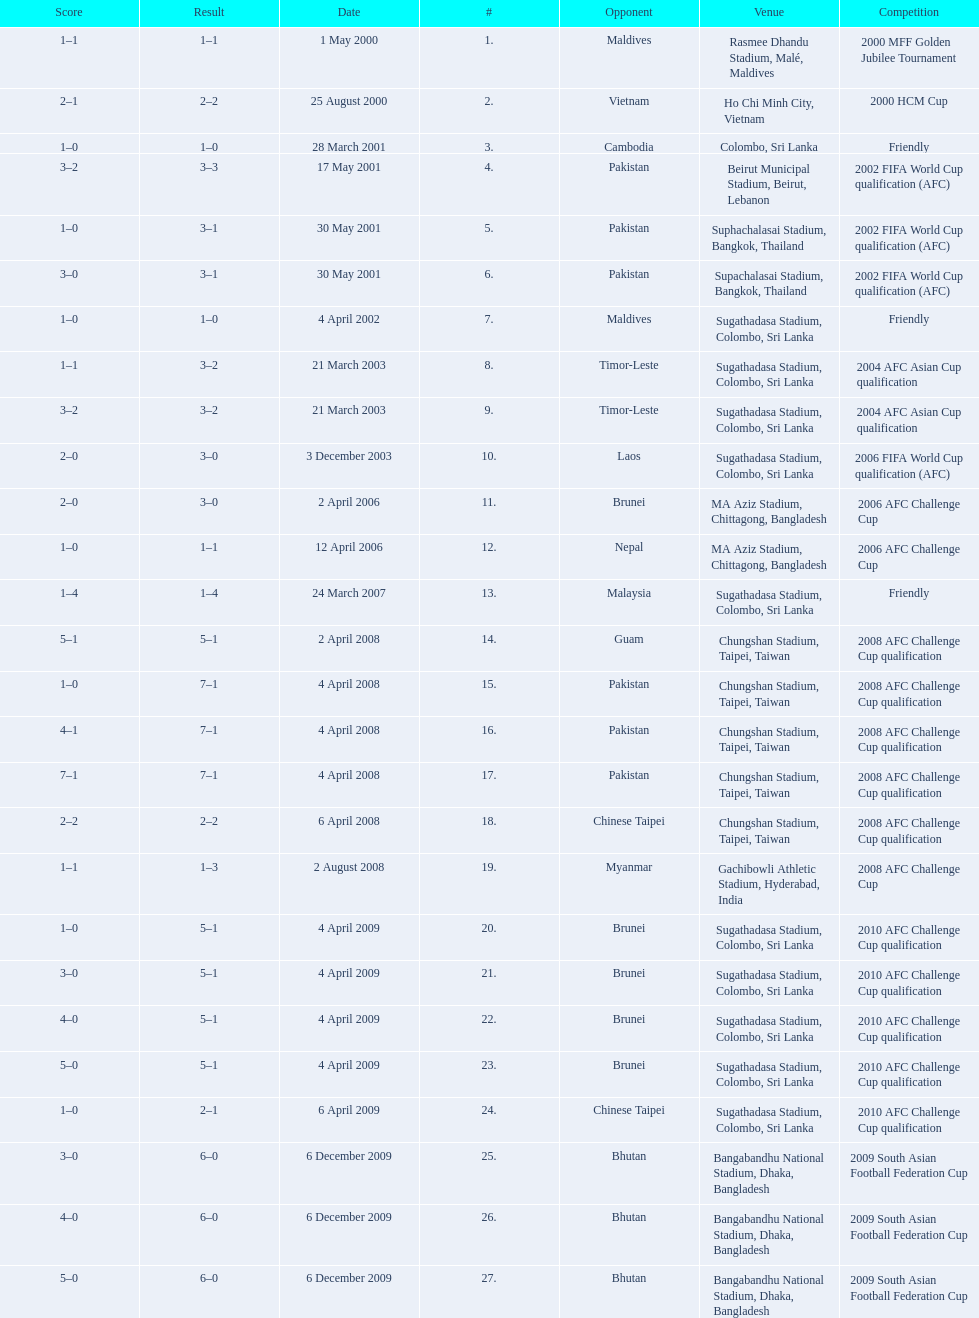Can you give me this table as a dict? {'header': ['Score', 'Result', 'Date', '#', 'Opponent', 'Venue', 'Competition'], 'rows': [['1–1', '1–1', '1 May 2000', '1.', 'Maldives', 'Rasmee Dhandu Stadium, Malé, Maldives', '2000 MFF Golden Jubilee Tournament'], ['2–1', '2–2', '25 August 2000', '2.', 'Vietnam', 'Ho Chi Minh City, Vietnam', '2000 HCM Cup'], ['1–0', '1–0', '28 March 2001', '3.', 'Cambodia', 'Colombo, Sri Lanka', 'Friendly'], ['3–2', '3–3', '17 May 2001', '4.', 'Pakistan', 'Beirut Municipal Stadium, Beirut, Lebanon', '2002 FIFA World Cup qualification (AFC)'], ['1–0', '3–1', '30 May 2001', '5.', 'Pakistan', 'Suphachalasai Stadium, Bangkok, Thailand', '2002 FIFA World Cup qualification (AFC)'], ['3–0', '3–1', '30 May 2001', '6.', 'Pakistan', 'Supachalasai Stadium, Bangkok, Thailand', '2002 FIFA World Cup qualification (AFC)'], ['1–0', '1–0', '4 April 2002', '7.', 'Maldives', 'Sugathadasa Stadium, Colombo, Sri Lanka', 'Friendly'], ['1–1', '3–2', '21 March 2003', '8.', 'Timor-Leste', 'Sugathadasa Stadium, Colombo, Sri Lanka', '2004 AFC Asian Cup qualification'], ['3–2', '3–2', '21 March 2003', '9.', 'Timor-Leste', 'Sugathadasa Stadium, Colombo, Sri Lanka', '2004 AFC Asian Cup qualification'], ['2–0', '3–0', '3 December 2003', '10.', 'Laos', 'Sugathadasa Stadium, Colombo, Sri Lanka', '2006 FIFA World Cup qualification (AFC)'], ['2–0', '3–0', '2 April 2006', '11.', 'Brunei', 'MA Aziz Stadium, Chittagong, Bangladesh', '2006 AFC Challenge Cup'], ['1–0', '1–1', '12 April 2006', '12.', 'Nepal', 'MA Aziz Stadium, Chittagong, Bangladesh', '2006 AFC Challenge Cup'], ['1–4', '1–4', '24 March 2007', '13.', 'Malaysia', 'Sugathadasa Stadium, Colombo, Sri Lanka', 'Friendly'], ['5–1', '5–1', '2 April 2008', '14.', 'Guam', 'Chungshan Stadium, Taipei, Taiwan', '2008 AFC Challenge Cup qualification'], ['1–0', '7–1', '4 April 2008', '15.', 'Pakistan', 'Chungshan Stadium, Taipei, Taiwan', '2008 AFC Challenge Cup qualification'], ['4–1', '7–1', '4 April 2008', '16.', 'Pakistan', 'Chungshan Stadium, Taipei, Taiwan', '2008 AFC Challenge Cup qualification'], ['7–1', '7–1', '4 April 2008', '17.', 'Pakistan', 'Chungshan Stadium, Taipei, Taiwan', '2008 AFC Challenge Cup qualification'], ['2–2', '2–2', '6 April 2008', '18.', 'Chinese Taipei', 'Chungshan Stadium, Taipei, Taiwan', '2008 AFC Challenge Cup qualification'], ['1–1', '1–3', '2 August 2008', '19.', 'Myanmar', 'Gachibowli Athletic Stadium, Hyderabad, India', '2008 AFC Challenge Cup'], ['1–0', '5–1', '4 April 2009', '20.', 'Brunei', 'Sugathadasa Stadium, Colombo, Sri Lanka', '2010 AFC Challenge Cup qualification'], ['3–0', '5–1', '4 April 2009', '21.', 'Brunei', 'Sugathadasa Stadium, Colombo, Sri Lanka', '2010 AFC Challenge Cup qualification'], ['4–0', '5–1', '4 April 2009', '22.', 'Brunei', 'Sugathadasa Stadium, Colombo, Sri Lanka', '2010 AFC Challenge Cup qualification'], ['5–0', '5–1', '4 April 2009', '23.', 'Brunei', 'Sugathadasa Stadium, Colombo, Sri Lanka', '2010 AFC Challenge Cup qualification'], ['1–0', '2–1', '6 April 2009', '24.', 'Chinese Taipei', 'Sugathadasa Stadium, Colombo, Sri Lanka', '2010 AFC Challenge Cup qualification'], ['3–0', '6–0', '6 December 2009', '25.', 'Bhutan', 'Bangabandhu National Stadium, Dhaka, Bangladesh', '2009 South Asian Football Federation Cup'], ['4–0', '6–0', '6 December 2009', '26.', 'Bhutan', 'Bangabandhu National Stadium, Dhaka, Bangladesh', '2009 South Asian Football Federation Cup'], ['5–0', '6–0', '6 December 2009', '27.', 'Bhutan', 'Bangabandhu National Stadium, Dhaka, Bangladesh', '2009 South Asian Football Federation Cup']]} What venues are listed? Rasmee Dhandu Stadium, Malé, Maldives, Ho Chi Minh City, Vietnam, Colombo, Sri Lanka, Beirut Municipal Stadium, Beirut, Lebanon, Suphachalasai Stadium, Bangkok, Thailand, MA Aziz Stadium, Chittagong, Bangladesh, Sugathadasa Stadium, Colombo, Sri Lanka, Chungshan Stadium, Taipei, Taiwan, Gachibowli Athletic Stadium, Hyderabad, India, Sugathadasa Stadium, Colombo, Sri Lanka, Bangabandhu National Stadium, Dhaka, Bangladesh. Which is top listed? Rasmee Dhandu Stadium, Malé, Maldives. 